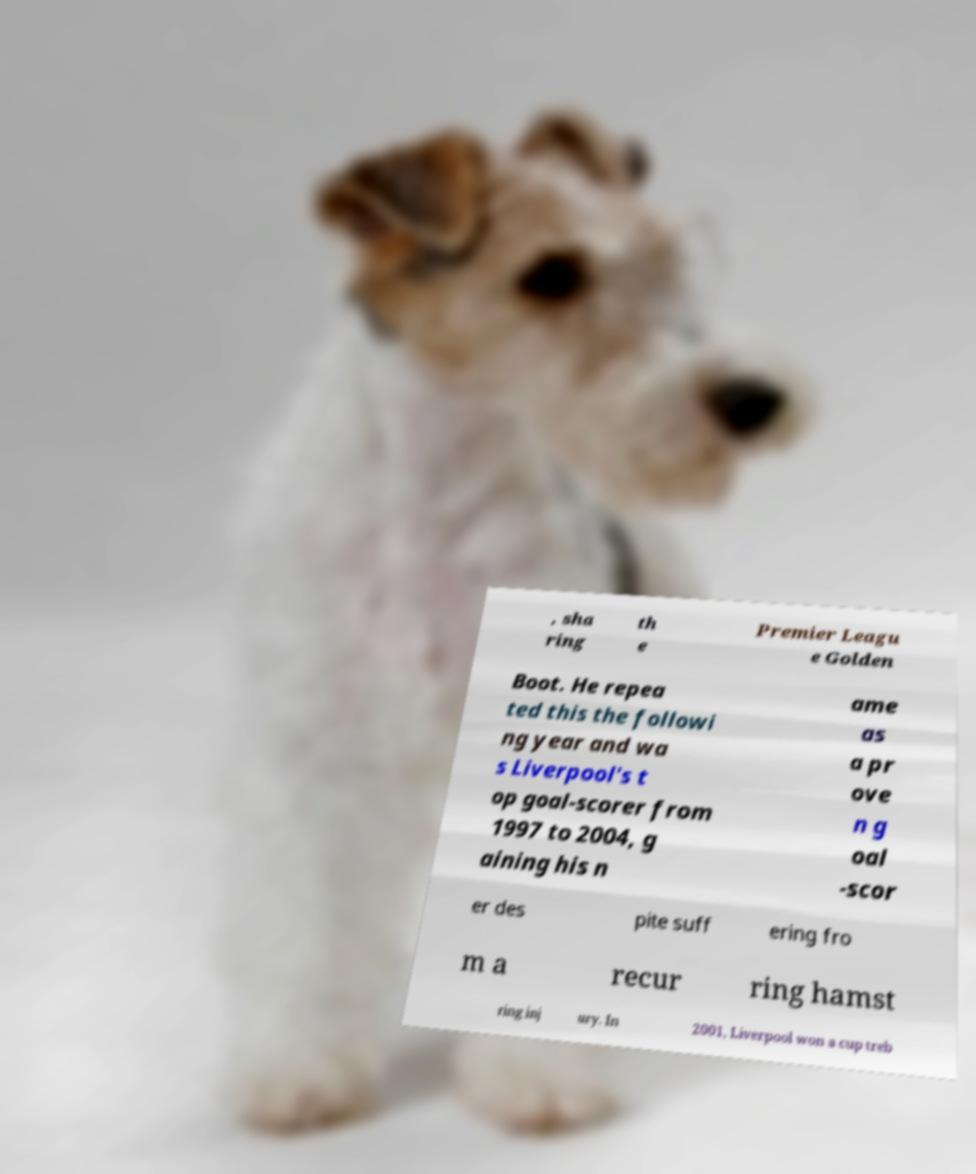Please read and relay the text visible in this image. What does it say? , sha ring th e Premier Leagu e Golden Boot. He repea ted this the followi ng year and wa s Liverpool's t op goal-scorer from 1997 to 2004, g aining his n ame as a pr ove n g oal -scor er des pite suff ering fro m a recur ring hamst ring inj ury. In 2001, Liverpool won a cup treb 